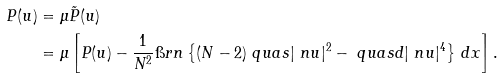<formula> <loc_0><loc_0><loc_500><loc_500>P ( u ) & = \mu \tilde { P } ( u ) \\ & = \mu \left [ P ( u ) - \frac { 1 } { N ^ { 2 } } \i r n \left \{ ( N - 2 ) \ q u a s | \ n u | ^ { 2 } - \ q u a s d | \ n u | ^ { 4 } \right \} \, d x \right ] .</formula> 